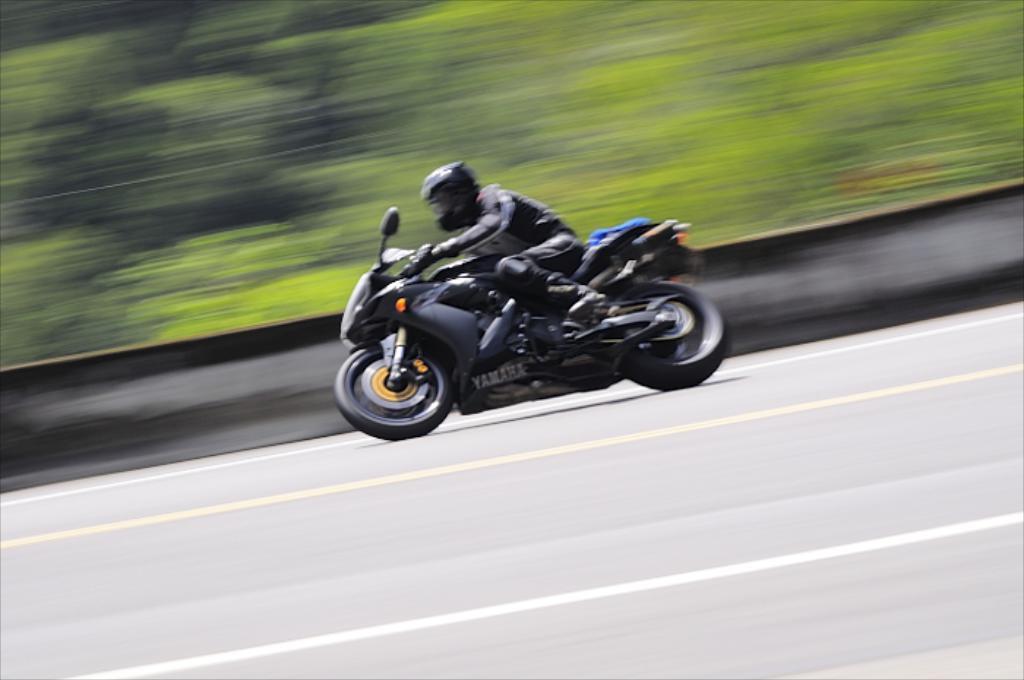Describe this image in one or two sentences. In this image we can see a person riding a bike on the road and the background is blurred. 